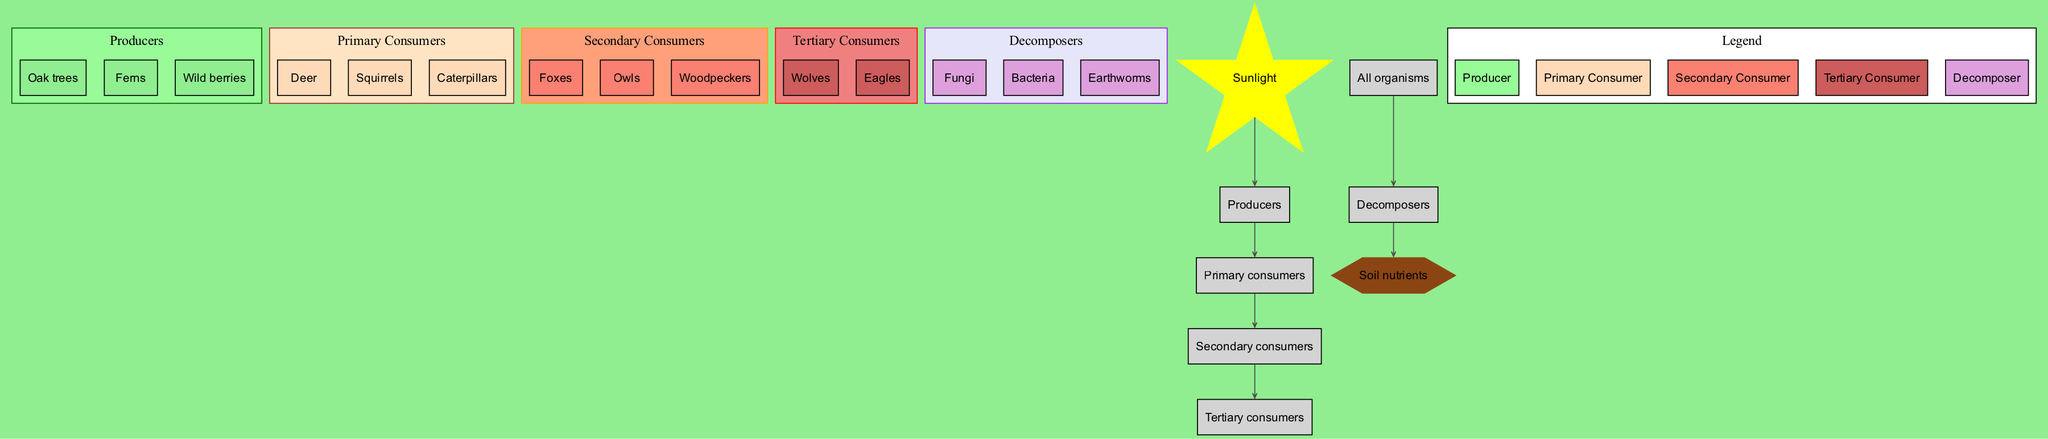What are the producers in this food chain? The diagram lists three producers: Oak trees, Ferns, and Wild berries. These are the foundational plants that convert sunlight into energy, forming the base of the food chain.
Answer: Oak trees, Ferns, Wild berries How many types of consumers are in the food chain? The diagram depicts three distinct levels of consumers: primary, secondary, and tertiary consumers. By counting these categories, we find a total of three types of consumers.
Answer: 3 Who is the primary consumer that feeds on caterpillars? The primary consumers identified in the diagram are Deer, Squirrels, and Caterpillars. Caterpillars are not predators and do not feed on other consumers; thus, the question seems to imply a misunderstanding of their role. They are consumers themselves and do not have a primary consumer feeding on them in this context. Therefore, the answer is none.
Answer: None Which organisms serve as decomposers in the ecosystem? According to the diagram, the decomposers include Fungi, Bacteria, and Earthworms. These organisms break down dead matter, returning nutrients to the soil and completing the ecosystem's cycle.
Answer: Fungi, Bacteria, Earthworms How many total arrows are drawn from decomposers to soil nutrients? The diagram illustrates a single arrow indicating the flow from decomposers to soil nutrients. This signifies that all decomposers contribute to feeding the soil with essential nutrients.
Answer: 1 Which type of consumer eats primarily deer? In the diagram, Secondary consumers include Foxes, Owls, and Woodpeckers. Among these, Foxes are known to prey on deer, indicating they are the primary consumer that eats deer.
Answer: Foxes How do primary consumers interact with producers? The diagram shows a clear relationship where primary consumers feed on the producers, which indicates that they rely on producers for their energy and sustenance. This forms a direct link as indicated by an arrow from producers to primary consumers.
Answer: Feed on Which organism is at the top of the food chain? The diagram identifies Wolves and Eagles as the tertiary consumers, occupying the highest position in the forest food chain. This indicates that they are top predators, having no natural enemies.
Answer: Wolves, Eagles What role do fungi play in the ecosystem? In the diagram, fungi are listed as decomposers, which means they help break down organic matter from dead plants and animals, recycling nutrients back into the ecosystem. They play a critical role in maintaining soil health and nutrient availability.
Answer: Decomposers 